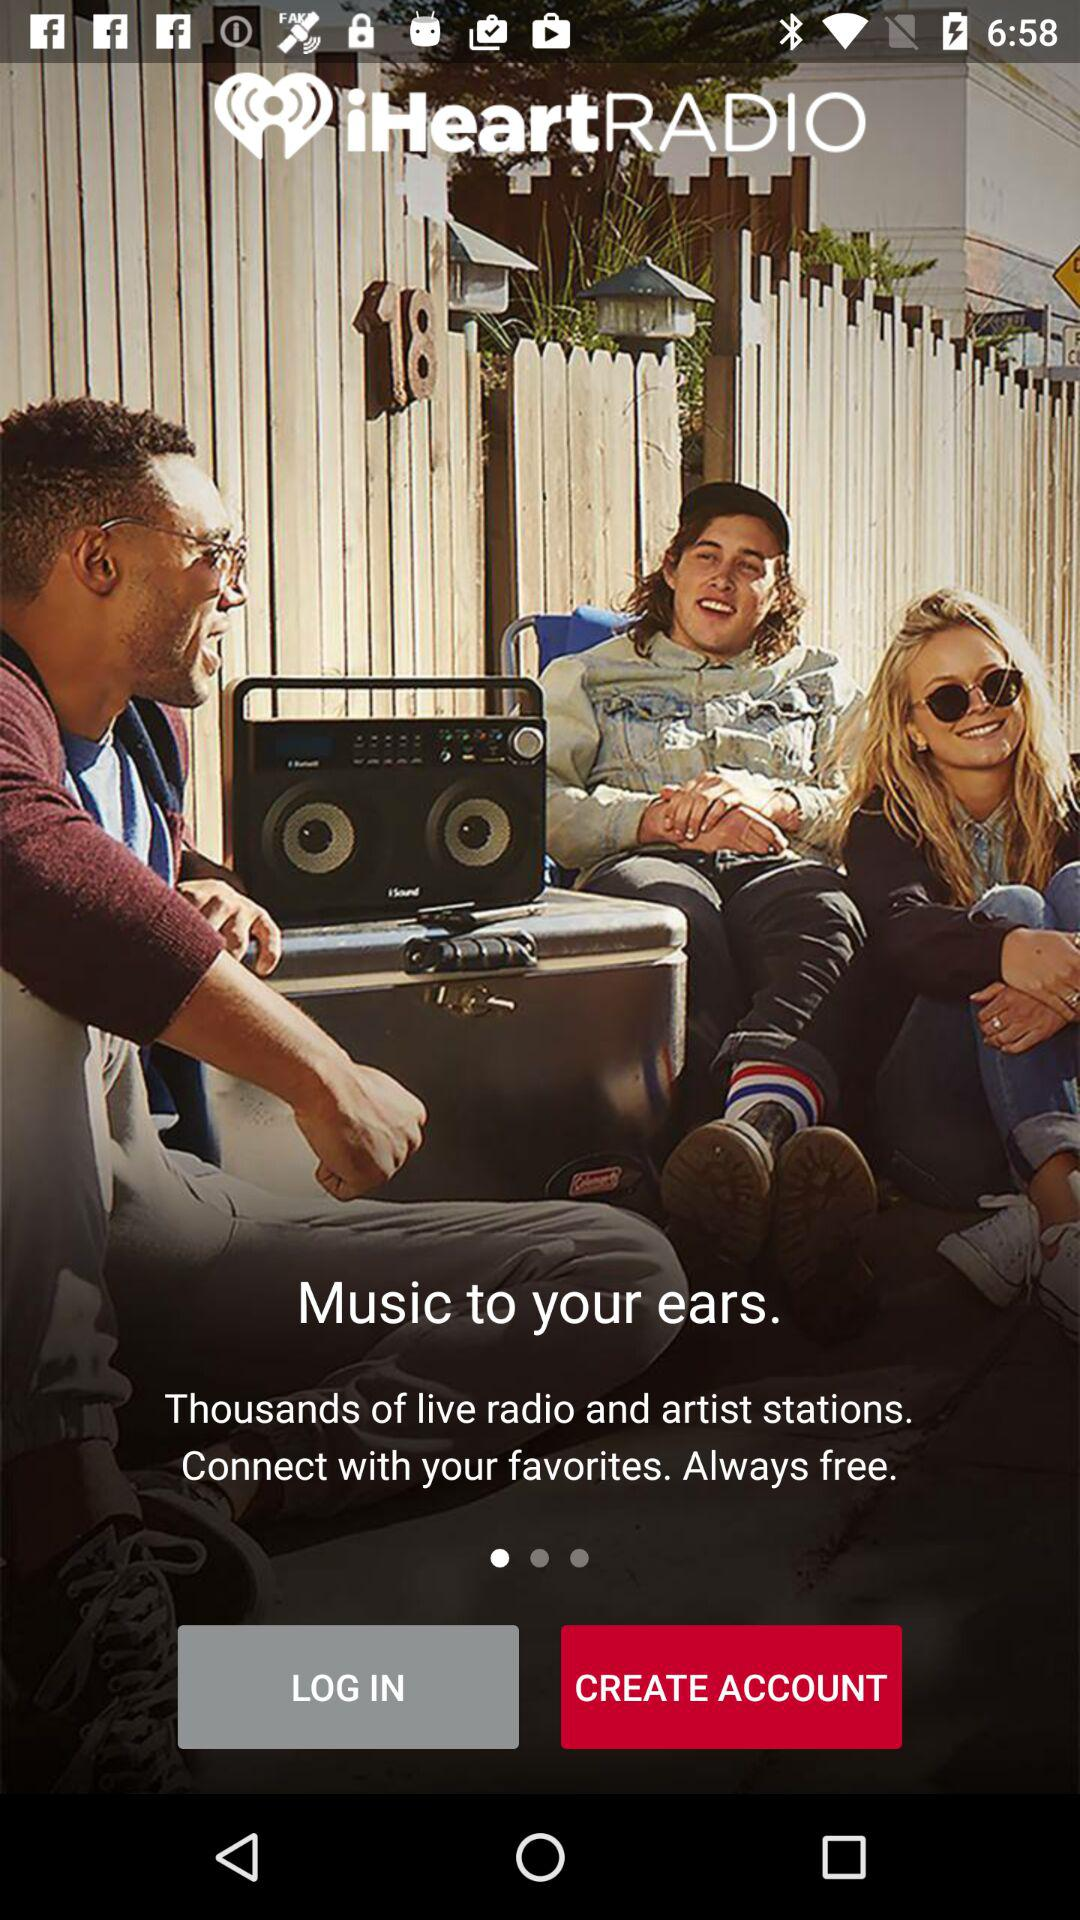What is the name of the application? The name of the application is "iHeartRADIO". 